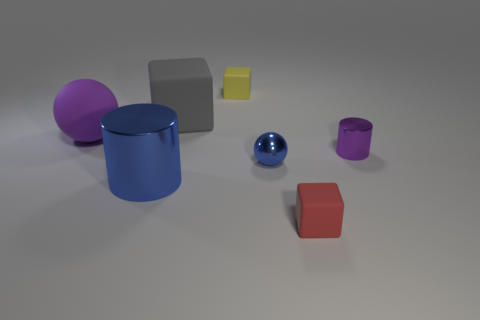Add 2 cylinders. How many objects exist? 9 Subtract all cubes. How many objects are left? 4 Subtract 0 green balls. How many objects are left? 7 Subtract all tiny matte objects. Subtract all tiny red things. How many objects are left? 4 Add 3 yellow cubes. How many yellow cubes are left? 4 Add 4 purple metallic spheres. How many purple metallic spheres exist? 4 